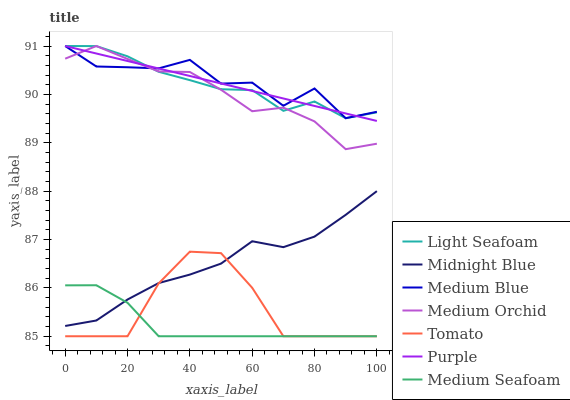Does Medium Seafoam have the minimum area under the curve?
Answer yes or no. Yes. Does Medium Blue have the maximum area under the curve?
Answer yes or no. Yes. Does Midnight Blue have the minimum area under the curve?
Answer yes or no. No. Does Midnight Blue have the maximum area under the curve?
Answer yes or no. No. Is Purple the smoothest?
Answer yes or no. Yes. Is Medium Blue the roughest?
Answer yes or no. Yes. Is Midnight Blue the smoothest?
Answer yes or no. No. Is Midnight Blue the roughest?
Answer yes or no. No. Does Tomato have the lowest value?
Answer yes or no. Yes. Does Midnight Blue have the lowest value?
Answer yes or no. No. Does Light Seafoam have the highest value?
Answer yes or no. Yes. Does Midnight Blue have the highest value?
Answer yes or no. No. Is Midnight Blue less than Purple?
Answer yes or no. Yes. Is Medium Orchid greater than Midnight Blue?
Answer yes or no. Yes. Does Medium Blue intersect Purple?
Answer yes or no. Yes. Is Medium Blue less than Purple?
Answer yes or no. No. Is Medium Blue greater than Purple?
Answer yes or no. No. Does Midnight Blue intersect Purple?
Answer yes or no. No. 